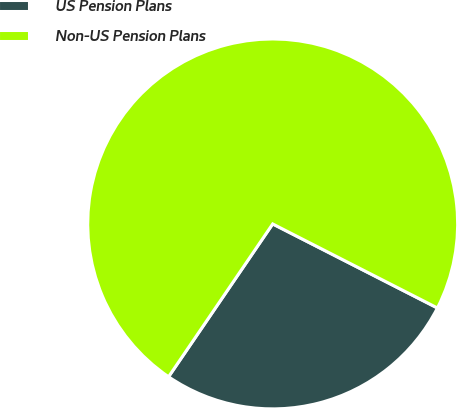<chart> <loc_0><loc_0><loc_500><loc_500><pie_chart><fcel>US Pension Plans<fcel>Non-US Pension Plans<nl><fcel>27.01%<fcel>72.99%<nl></chart> 